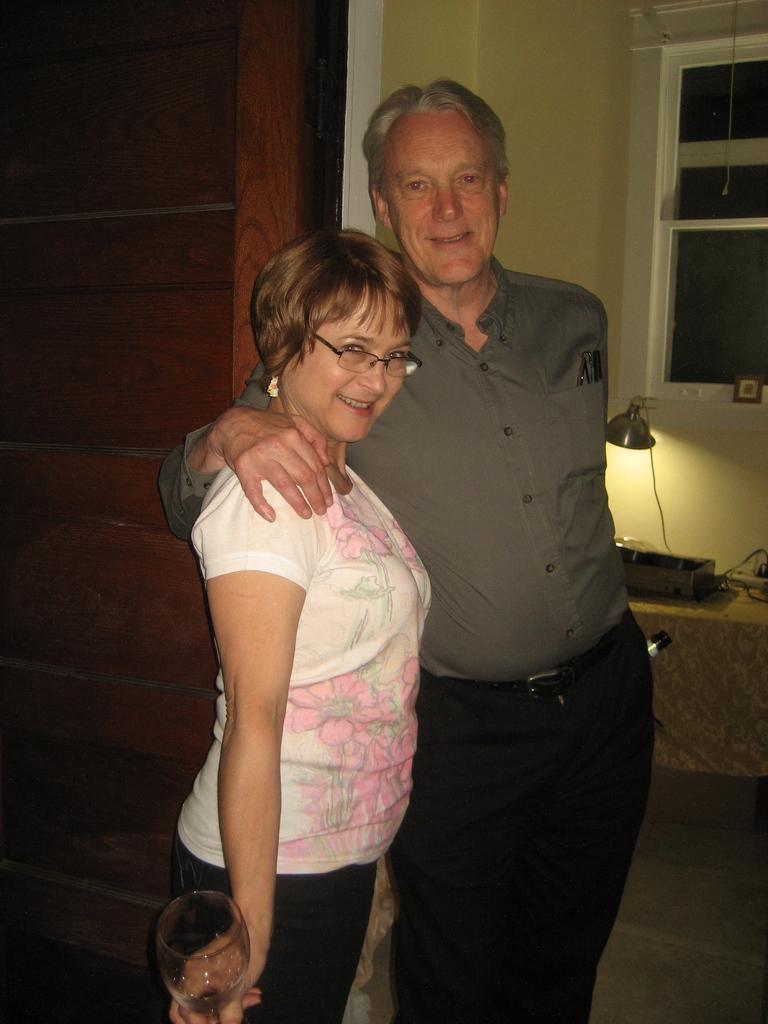Please provide a concise description of this image. In this picture we can see a man and a woman standing and smiling. We can see this woman holding a glass. There is a lamp, wooden door, some objects, a window and the wall in the background. 